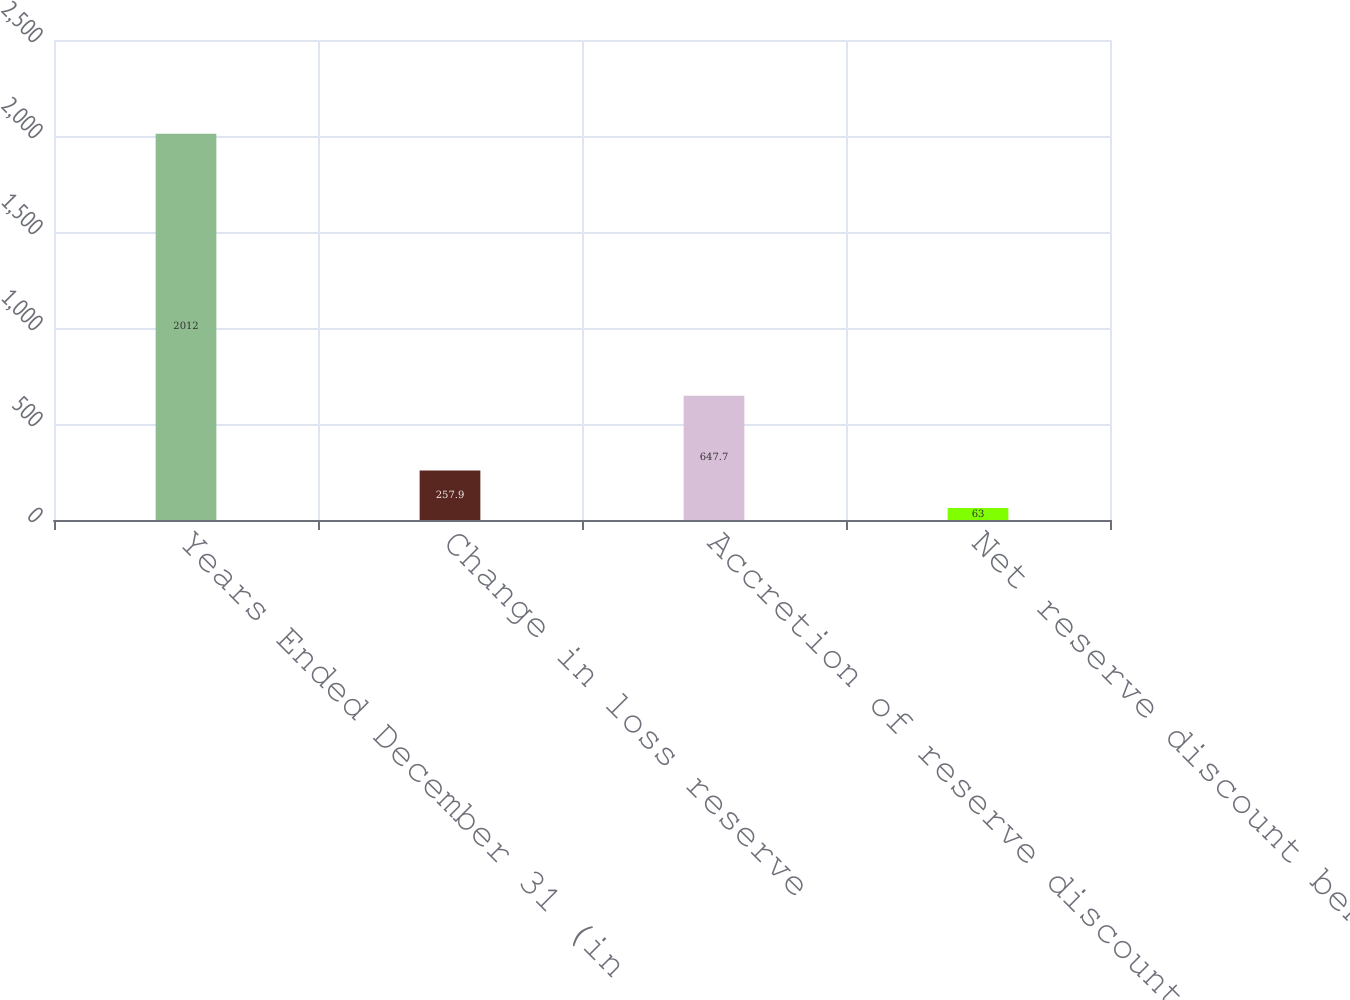Convert chart. <chart><loc_0><loc_0><loc_500><loc_500><bar_chart><fcel>Years Ended December 31 (in<fcel>Change in loss reserve<fcel>Accretion of reserve discount<fcel>Net reserve discount benefit<nl><fcel>2012<fcel>257.9<fcel>647.7<fcel>63<nl></chart> 